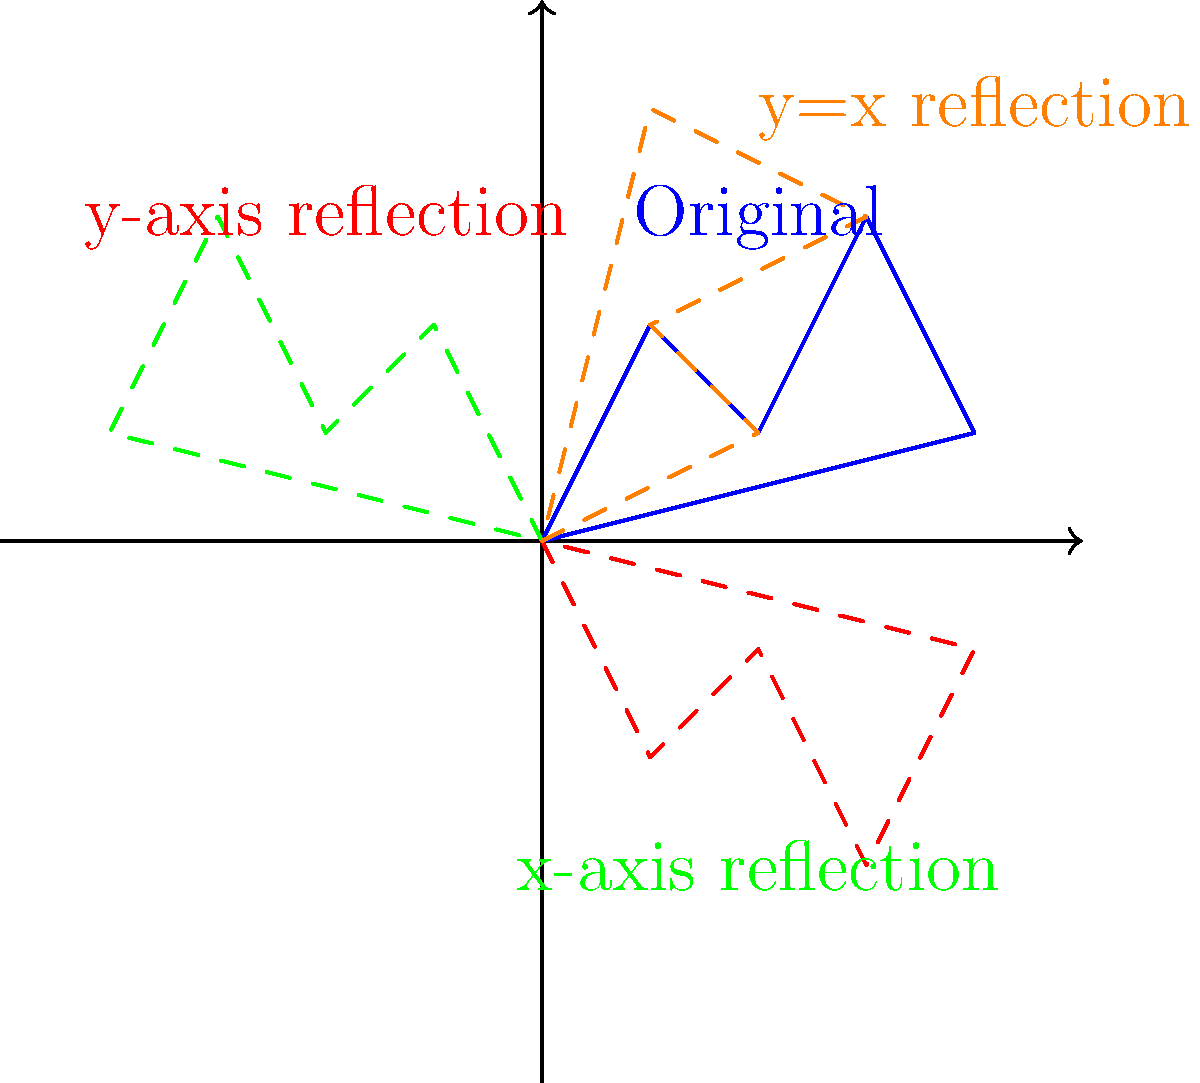As an aspiring artist inspired by Amelia Opdyke Jones's vintage advertisement style, you've sketched a simple design and want to explore its transformations. The original sketch is shown in blue, and its reflections across different axes are displayed in various colors. Which reflection represents the transformation of the original sketch across the line $y=x$? To identify the reflection across the line $y=x$, let's analyze each reflection:

1. The original sketch is in blue.

2. The red dashed line shows a reflection across the y-axis. This flips the sketch horizontally.

3. The green dashed line shows a reflection across the x-axis. This flips the sketch vertically.

4. The orange dashed line shows a reflection across the line $y=x$. This line passes through the origin at a 45-degree angle.

A reflection across $y=x$ has the following properties:
- It swaps the x and y coordinates of each point.
- The resulting shape appears to be flipped diagonally.

Looking at the orange dashed line, we can see that it exhibits these properties:
- It's neither a horizontal nor a vertical flip.
- The shape appears to be rotated 90 degrees and then flipped vertically.

Therefore, the orange dashed line represents the reflection across $y=x$.
Answer: Orange dashed line 